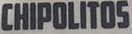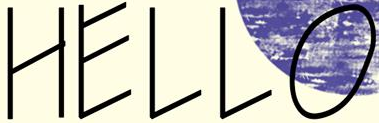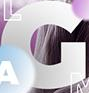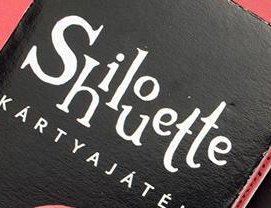What words can you see in these images in sequence, separated by a semicolon? CHIPOLITOS; HELLO; G; Shilouette 